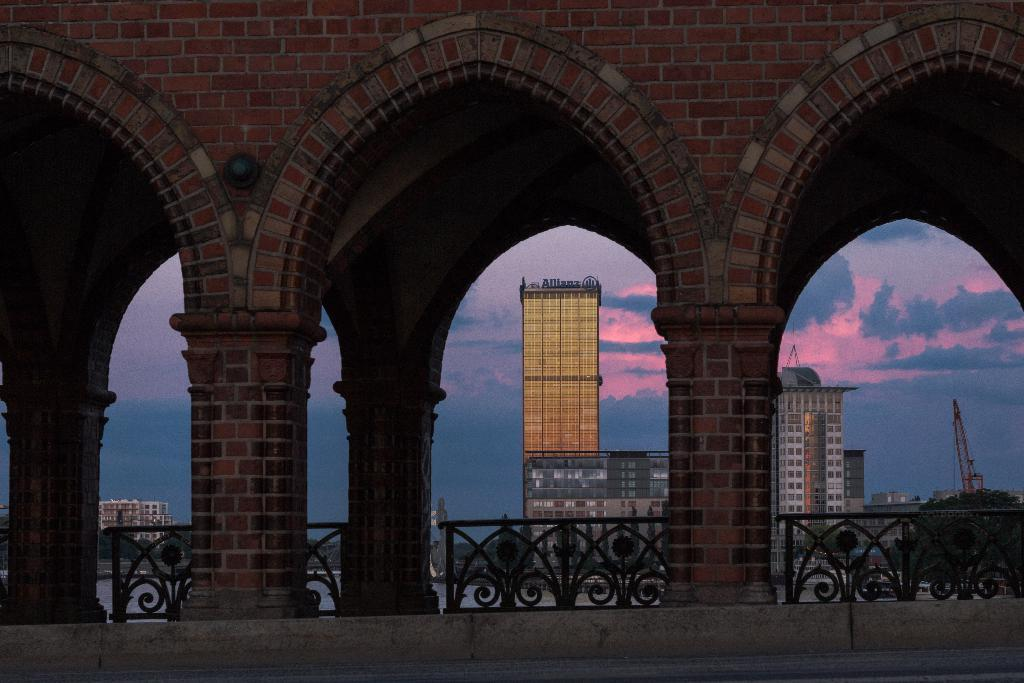What type of structure can be seen in the image? There is a wall in the image. Are there any other architectural features visible? Yes, there are pillars and a fence in the image. What type of environment is depicted in the image? There are buildings and water visible in the image. What is happening on the road in the image? There are vehicles on the road in the image. What part of the natural environment is visible in the image? The sky is visible in the image. What letters are being used to spell out a message on the train in the image? There is no train present in the image; it features a wall, pillars, fence, buildings, water, vehicles, and the sky. 